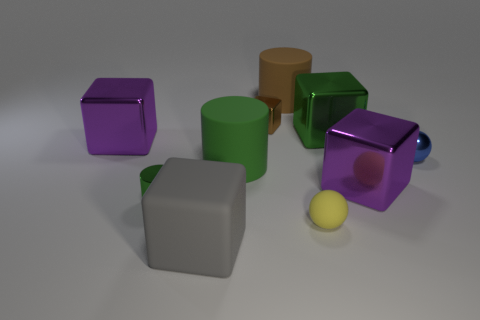How many purple cubes must be subtracted to get 1 purple cubes? 1 Subtract 1 cubes. How many cubes are left? 4 Subtract all brown cubes. How many cubes are left? 4 Subtract all big gray rubber blocks. How many blocks are left? 4 Subtract all red cubes. Subtract all gray spheres. How many cubes are left? 5 Subtract all balls. How many objects are left? 8 Add 4 large metallic cubes. How many large metallic cubes are left? 7 Add 9 big brown cylinders. How many big brown cylinders exist? 10 Subtract 0 blue cubes. How many objects are left? 10 Subtract all green cylinders. Subtract all tiny metal cylinders. How many objects are left? 7 